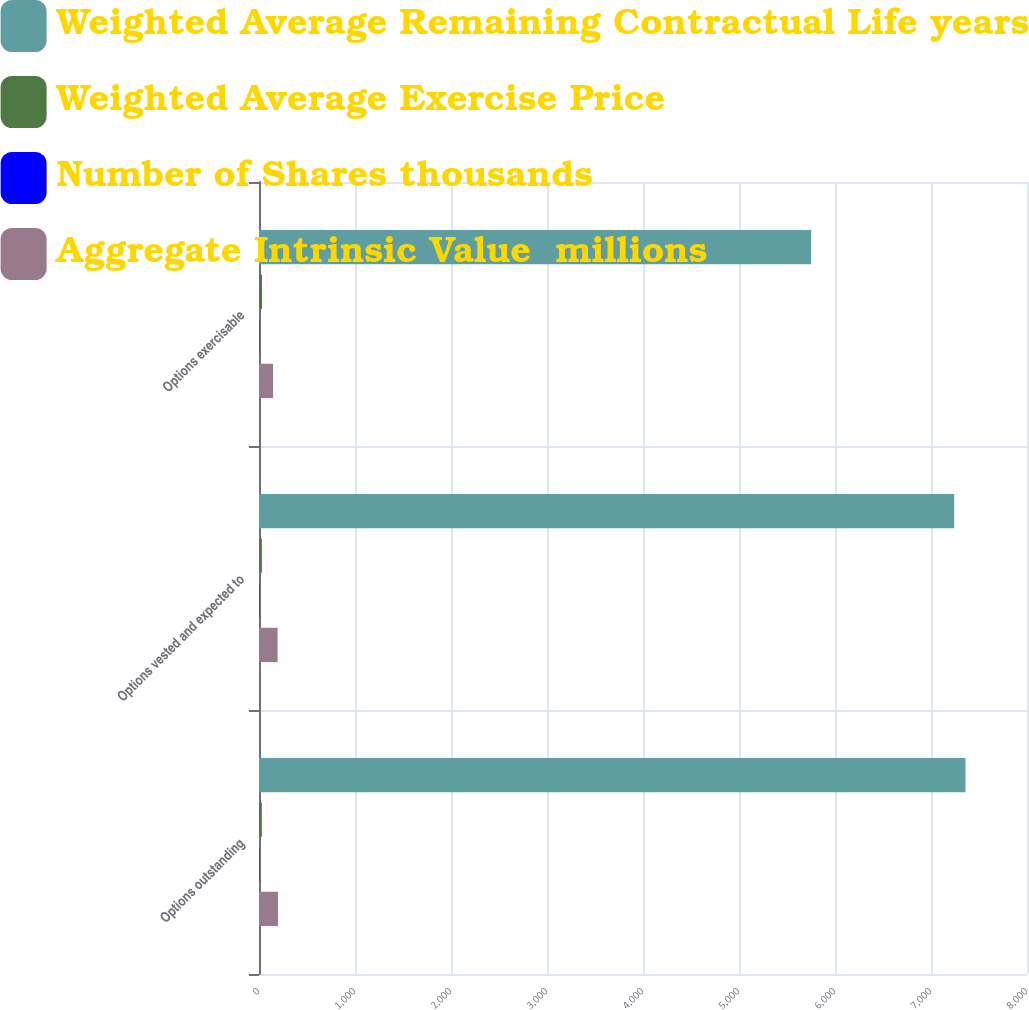Convert chart. <chart><loc_0><loc_0><loc_500><loc_500><stacked_bar_chart><ecel><fcel>Options outstanding<fcel>Options vested and expected to<fcel>Options exercisable<nl><fcel>Weighted Average Remaining Contractual Life years<fcel>7359<fcel>7242<fcel>5752<nl><fcel>Weighted Average Exercise Price<fcel>29.93<fcel>30.05<fcel>31.28<nl><fcel>Number of Shares thousands<fcel>3.22<fcel>3.18<fcel>2.65<nl><fcel>Aggregate Intrinsic Value  millions<fcel>197.6<fcel>193.6<fcel>146.7<nl></chart> 